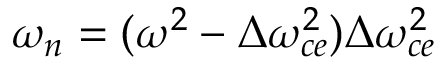<formula> <loc_0><loc_0><loc_500><loc_500>\omega _ { n } = ( \omega ^ { 2 } - \Delta \omega _ { c e } ^ { 2 } ) \Delta \omega _ { c e } ^ { 2 }</formula> 